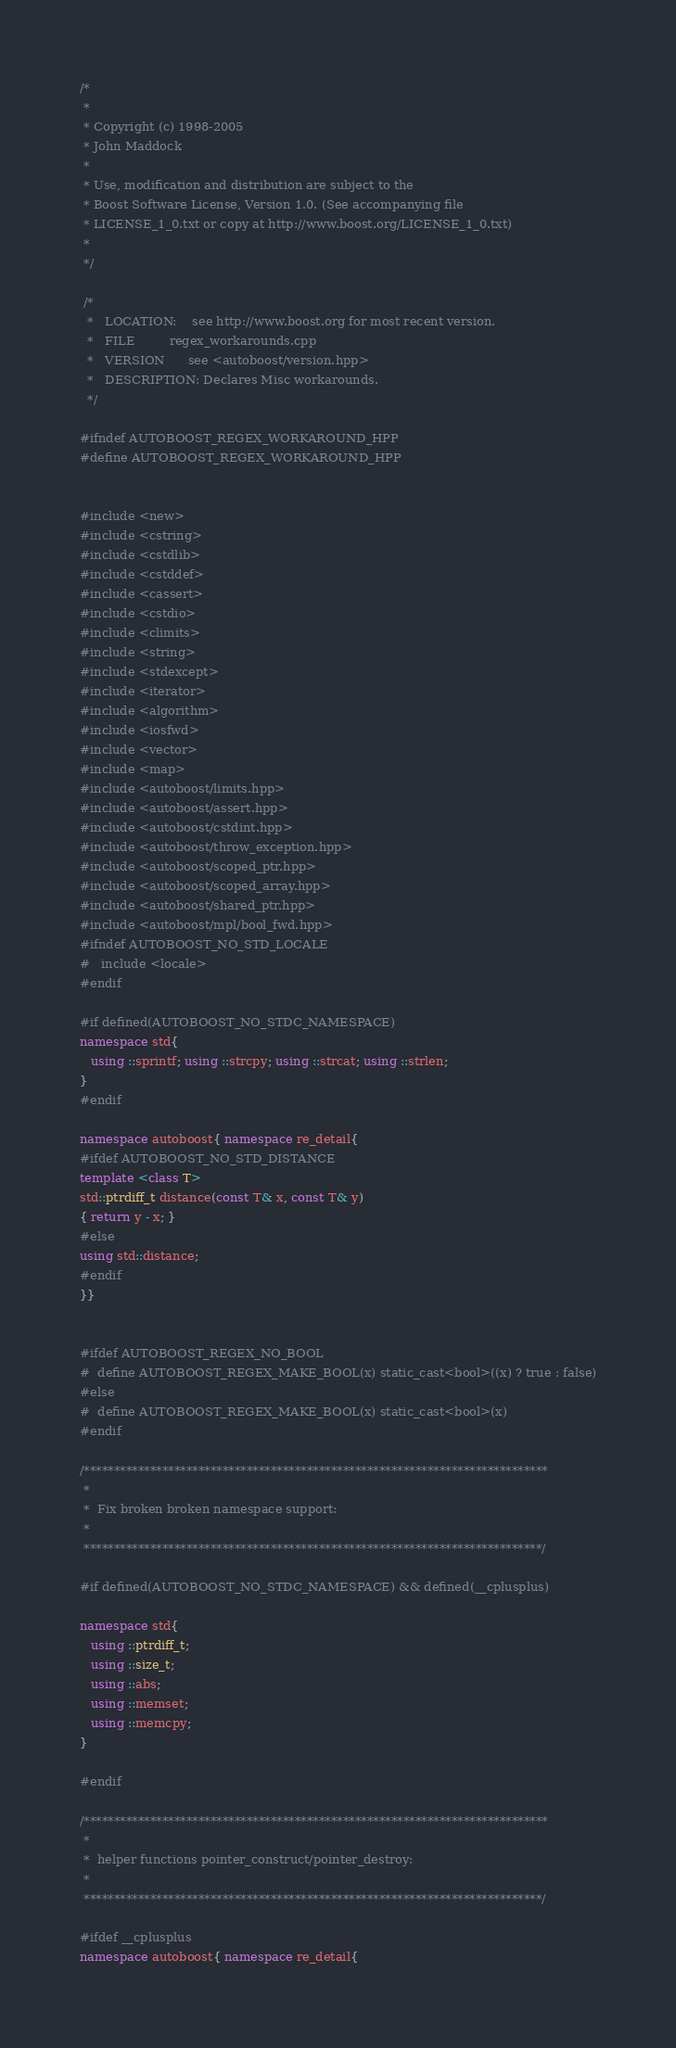<code> <loc_0><loc_0><loc_500><loc_500><_C++_>/*
 *
 * Copyright (c) 1998-2005
 * John Maddock
 *
 * Use, modification and distribution are subject to the
 * Boost Software License, Version 1.0. (See accompanying file
 * LICENSE_1_0.txt or copy at http://www.boost.org/LICENSE_1_0.txt)
 *
 */

 /*
  *   LOCATION:    see http://www.boost.org for most recent version.
  *   FILE         regex_workarounds.cpp
  *   VERSION      see <autoboost/version.hpp>
  *   DESCRIPTION: Declares Misc workarounds.
  */

#ifndef AUTOBOOST_REGEX_WORKAROUND_HPP
#define AUTOBOOST_REGEX_WORKAROUND_HPP


#include <new>
#include <cstring>
#include <cstdlib>
#include <cstddef>
#include <cassert>
#include <cstdio>
#include <climits>
#include <string>
#include <stdexcept>
#include <iterator>
#include <algorithm>
#include <iosfwd>
#include <vector>
#include <map>
#include <autoboost/limits.hpp>
#include <autoboost/assert.hpp>
#include <autoboost/cstdint.hpp>
#include <autoboost/throw_exception.hpp>
#include <autoboost/scoped_ptr.hpp>
#include <autoboost/scoped_array.hpp>
#include <autoboost/shared_ptr.hpp>
#include <autoboost/mpl/bool_fwd.hpp>
#ifndef AUTOBOOST_NO_STD_LOCALE
#   include <locale>
#endif

#if defined(AUTOBOOST_NO_STDC_NAMESPACE)
namespace std{
   using ::sprintf; using ::strcpy; using ::strcat; using ::strlen;
}
#endif

namespace autoboost{ namespace re_detail{
#ifdef AUTOBOOST_NO_STD_DISTANCE
template <class T>
std::ptrdiff_t distance(const T& x, const T& y)
{ return y - x; }
#else
using std::distance;
#endif
}}


#ifdef AUTOBOOST_REGEX_NO_BOOL
#  define AUTOBOOST_REGEX_MAKE_BOOL(x) static_cast<bool>((x) ? true : false)
#else
#  define AUTOBOOST_REGEX_MAKE_BOOL(x) static_cast<bool>(x)
#endif

/*****************************************************************************
 *
 *  Fix broken broken namespace support:
 *
 ****************************************************************************/

#if defined(AUTOBOOST_NO_STDC_NAMESPACE) && defined(__cplusplus)

namespace std{
   using ::ptrdiff_t;
   using ::size_t;
   using ::abs;
   using ::memset;
   using ::memcpy;
}

#endif

/*****************************************************************************
 *
 *  helper functions pointer_construct/pointer_destroy:
 *
 ****************************************************************************/

#ifdef __cplusplus
namespace autoboost{ namespace re_detail{
</code> 